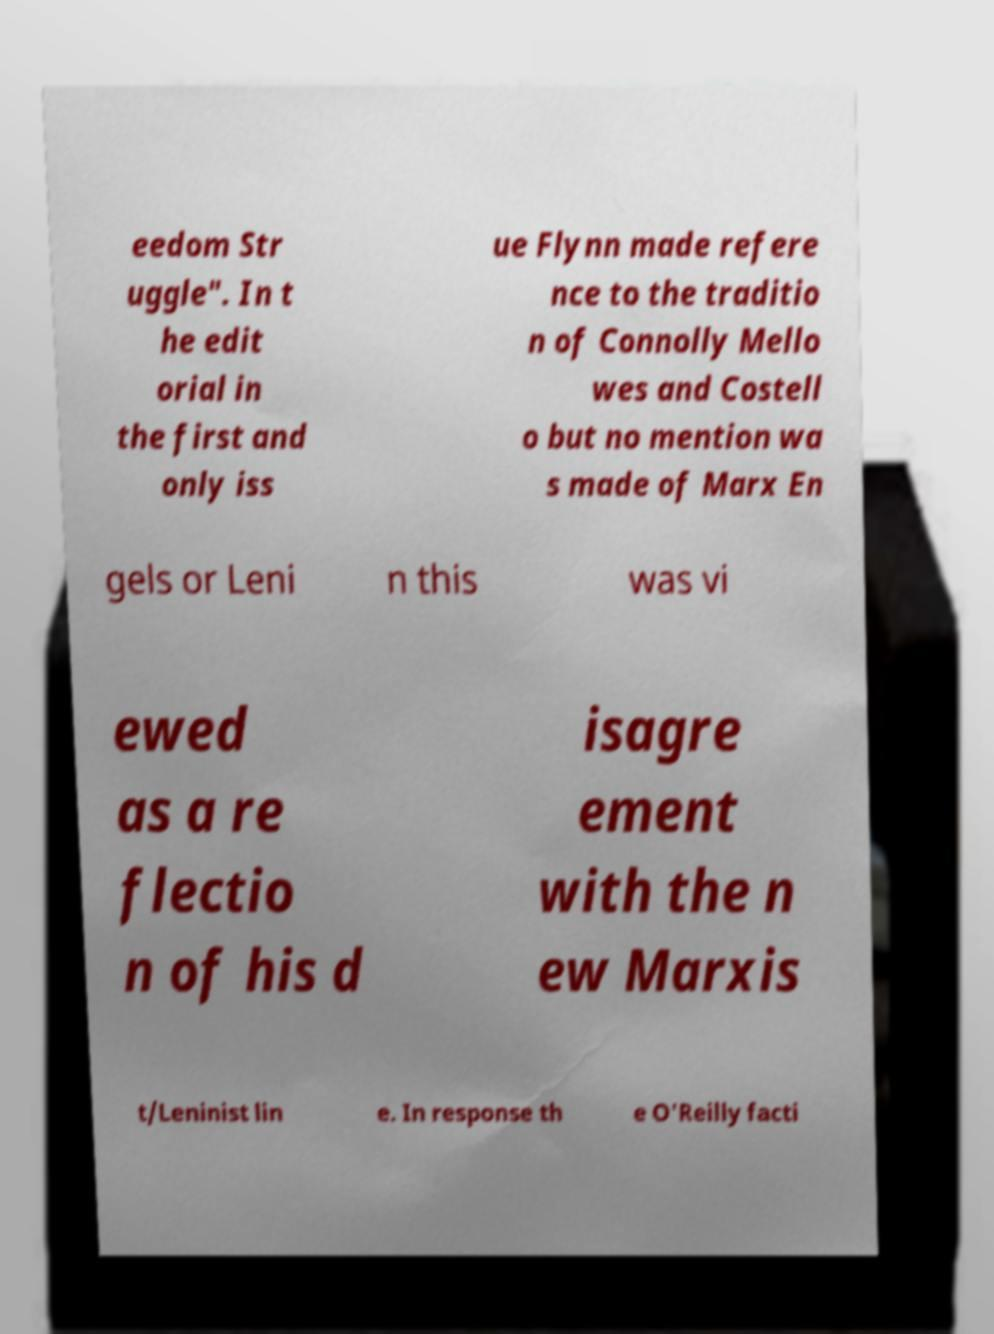What messages or text are displayed in this image? I need them in a readable, typed format. eedom Str uggle". In t he edit orial in the first and only iss ue Flynn made refere nce to the traditio n of Connolly Mello wes and Costell o but no mention wa s made of Marx En gels or Leni n this was vi ewed as a re flectio n of his d isagre ement with the n ew Marxis t/Leninist lin e. In response th e O'Reilly facti 